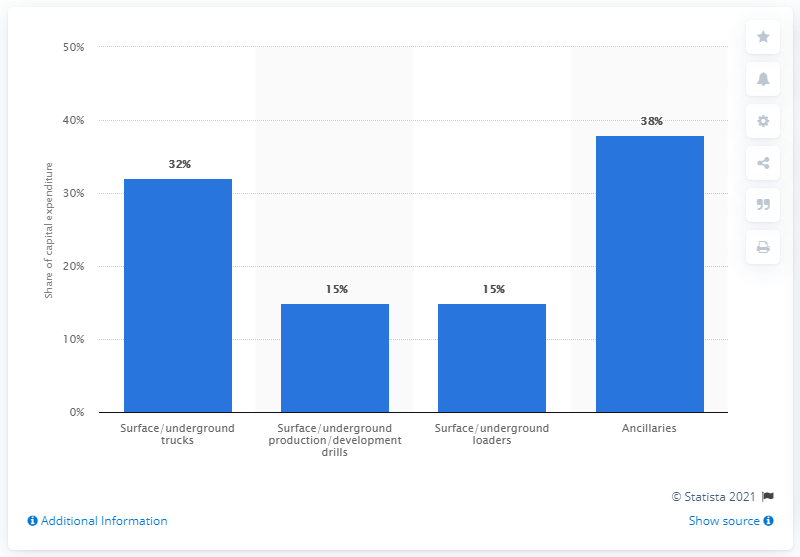Specify some key components in this picture. According to our data, 32% of the global capex on mobile mining equipment was allocated to the purchase of surface and underground trucks. 